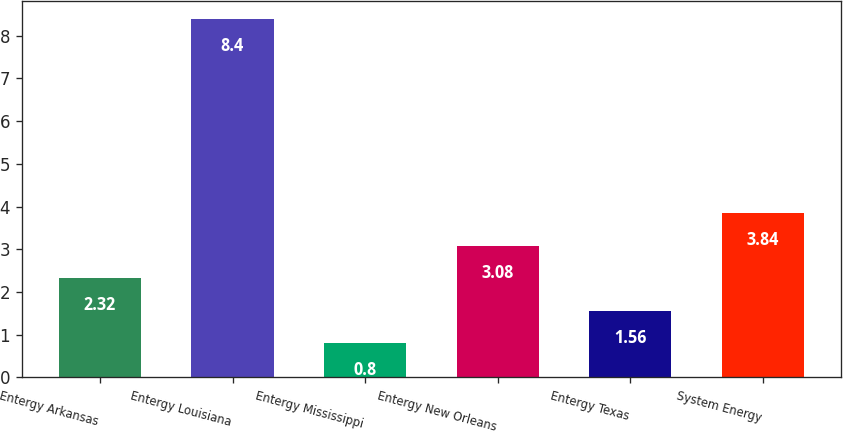Convert chart. <chart><loc_0><loc_0><loc_500><loc_500><bar_chart><fcel>Entergy Arkansas<fcel>Entergy Louisiana<fcel>Entergy Mississippi<fcel>Entergy New Orleans<fcel>Entergy Texas<fcel>System Energy<nl><fcel>2.32<fcel>8.4<fcel>0.8<fcel>3.08<fcel>1.56<fcel>3.84<nl></chart> 